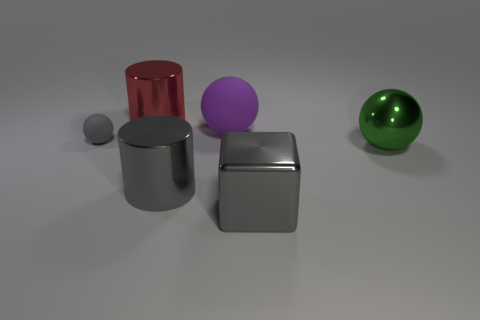There is a small gray object that is in front of the big rubber thing; what is it made of? The small gray object in front of the large rubber-like object appears to be made of a metallic material, given its reflective surface and the way it interacts with the light in the environment. 